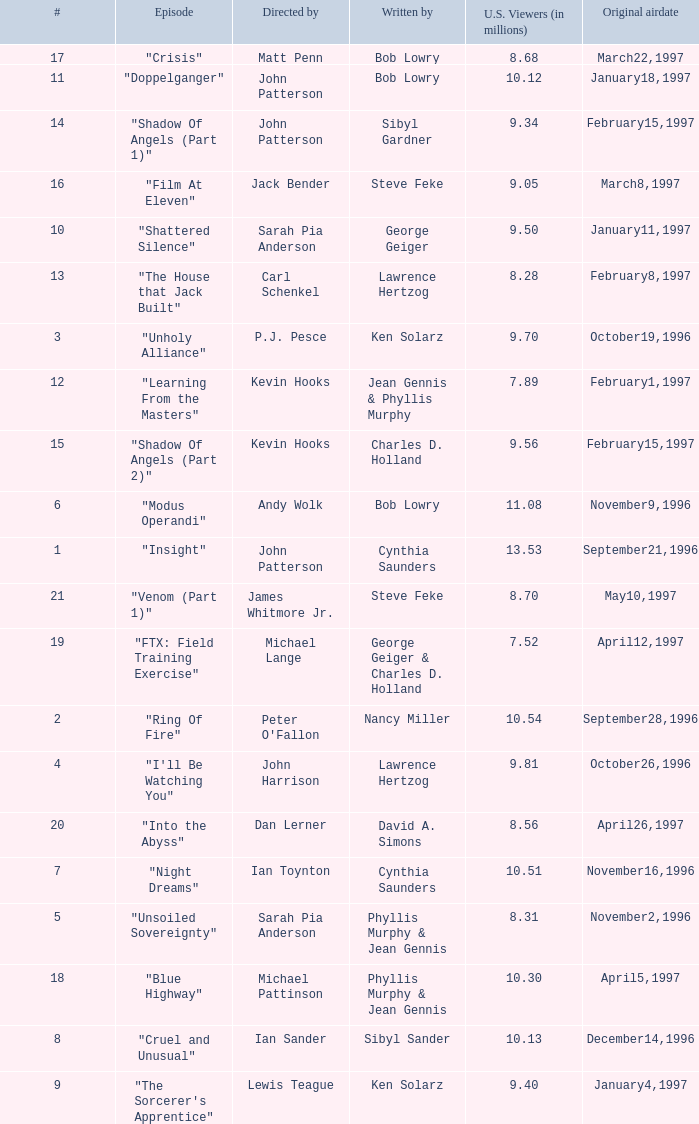Who wrote the episode with 7.52 million US viewers? George Geiger & Charles D. Holland. 